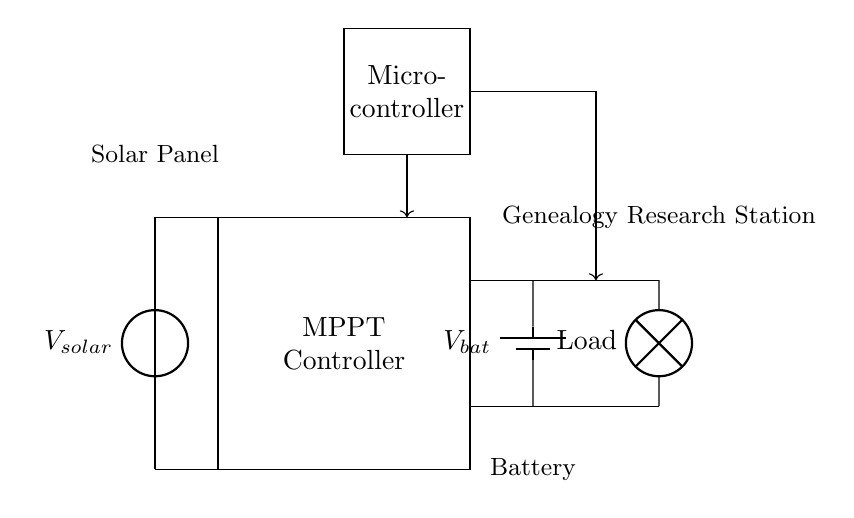What component represents the power source? The power source in the circuit is the solar panel indicated at the left side labeled with $V_{solar}$.
Answer: Solar Panel What does MPPT stand for? MPPT stands for Maximum Power Point Tracking, which is the component that optimizes the power output from the solar panel.
Answer: Maximum Power Point Tracking How many batteries are shown in the circuit? The circuit diagram includes one battery, which is represented on the right side labeled with $V_{bat}$.
Answer: One What is the purpose of the Micro-controller? The Micro-controller manages the operation of the MPPT controller and ensures efficient energy transfer, as indicated by its connections and control lines.
Answer: Management Describe the main load in the circuit. The load is illustrated as a lamp which is indicated on the right side of the battery connection, providing an electrical task for the power system.
Answer: Lamp How are the battery and load connected? The battery and load are connected in parallel with two connections from the battery terminals leading directly to the load.
Answer: Parallel What is the relationship between the solar panel and the MPPT controller? The solar panel provides power to the MPPT controller, which regulates the energy harvested to maximize efficiency before charging the battery.
Answer: Provides power 